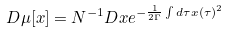Convert formula to latex. <formula><loc_0><loc_0><loc_500><loc_500>D \mu [ x ] = N ^ { - 1 } D x e ^ { - \frac { 1 } { 2 \Gamma } \int d \tau x ( \tau ) ^ { 2 } }</formula> 